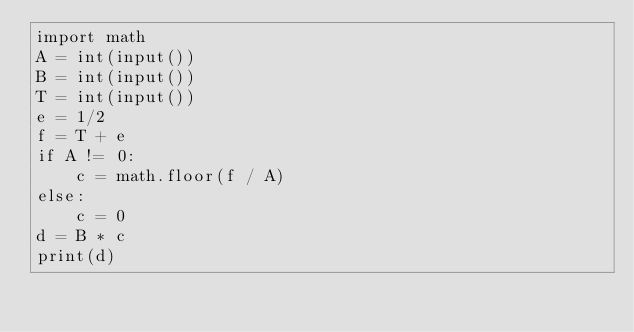Convert code to text. <code><loc_0><loc_0><loc_500><loc_500><_Python_>import math
A = int(input())
B = int(input())
T = int(input())
e = 1/2
f = T + e
if A != 0:
    c = math.floor(f / A)
else:
    c = 0
d = B * c
print(d)</code> 